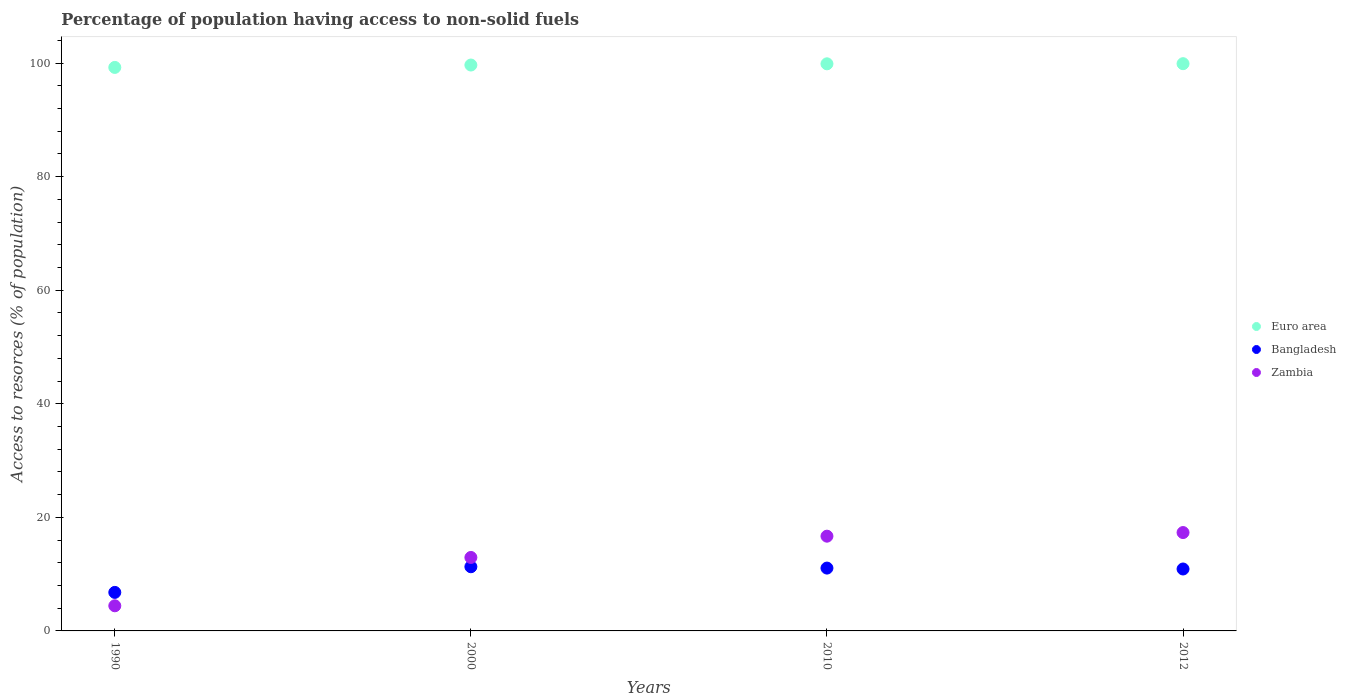What is the percentage of population having access to non-solid fuels in Euro area in 2010?
Offer a very short reply. 99.87. Across all years, what is the maximum percentage of population having access to non-solid fuels in Zambia?
Offer a terse response. 17.32. Across all years, what is the minimum percentage of population having access to non-solid fuels in Bangladesh?
Keep it short and to the point. 6.78. In which year was the percentage of population having access to non-solid fuels in Euro area minimum?
Your answer should be very brief. 1990. What is the total percentage of population having access to non-solid fuels in Euro area in the graph?
Ensure brevity in your answer.  398.65. What is the difference between the percentage of population having access to non-solid fuels in Euro area in 1990 and that in 2010?
Offer a very short reply. -0.64. What is the difference between the percentage of population having access to non-solid fuels in Zambia in 2000 and the percentage of population having access to non-solid fuels in Euro area in 2010?
Your answer should be compact. -86.93. What is the average percentage of population having access to non-solid fuels in Euro area per year?
Provide a succinct answer. 99.66. In the year 2012, what is the difference between the percentage of population having access to non-solid fuels in Bangladesh and percentage of population having access to non-solid fuels in Euro area?
Provide a short and direct response. -88.99. What is the ratio of the percentage of population having access to non-solid fuels in Bangladesh in 1990 to that in 2000?
Your response must be concise. 0.6. What is the difference between the highest and the second highest percentage of population having access to non-solid fuels in Euro area?
Make the answer very short. 0.02. What is the difference between the highest and the lowest percentage of population having access to non-solid fuels in Euro area?
Provide a succinct answer. 0.66. Is the sum of the percentage of population having access to non-solid fuels in Zambia in 1990 and 2000 greater than the maximum percentage of population having access to non-solid fuels in Euro area across all years?
Provide a short and direct response. No. Does the percentage of population having access to non-solid fuels in Zambia monotonically increase over the years?
Your answer should be very brief. Yes. Is the percentage of population having access to non-solid fuels in Bangladesh strictly greater than the percentage of population having access to non-solid fuels in Zambia over the years?
Give a very brief answer. No. How many years are there in the graph?
Offer a very short reply. 4. Does the graph contain grids?
Keep it short and to the point. No. Where does the legend appear in the graph?
Make the answer very short. Center right. How many legend labels are there?
Provide a short and direct response. 3. How are the legend labels stacked?
Provide a succinct answer. Vertical. What is the title of the graph?
Make the answer very short. Percentage of population having access to non-solid fuels. What is the label or title of the Y-axis?
Ensure brevity in your answer.  Access to resorces (% of population). What is the Access to resorces (% of population) in Euro area in 1990?
Your response must be concise. 99.23. What is the Access to resorces (% of population) in Bangladesh in 1990?
Ensure brevity in your answer.  6.78. What is the Access to resorces (% of population) in Zambia in 1990?
Offer a terse response. 4.42. What is the Access to resorces (% of population) of Euro area in 2000?
Your response must be concise. 99.66. What is the Access to resorces (% of population) in Bangladesh in 2000?
Offer a very short reply. 11.3. What is the Access to resorces (% of population) in Zambia in 2000?
Make the answer very short. 12.94. What is the Access to resorces (% of population) of Euro area in 2010?
Your response must be concise. 99.87. What is the Access to resorces (% of population) in Bangladesh in 2010?
Your response must be concise. 11.07. What is the Access to resorces (% of population) of Zambia in 2010?
Give a very brief answer. 16.69. What is the Access to resorces (% of population) of Euro area in 2012?
Your answer should be compact. 99.89. What is the Access to resorces (% of population) in Bangladesh in 2012?
Provide a succinct answer. 10.91. What is the Access to resorces (% of population) in Zambia in 2012?
Your answer should be very brief. 17.32. Across all years, what is the maximum Access to resorces (% of population) in Euro area?
Give a very brief answer. 99.89. Across all years, what is the maximum Access to resorces (% of population) of Bangladesh?
Give a very brief answer. 11.3. Across all years, what is the maximum Access to resorces (% of population) of Zambia?
Keep it short and to the point. 17.32. Across all years, what is the minimum Access to resorces (% of population) of Euro area?
Your answer should be compact. 99.23. Across all years, what is the minimum Access to resorces (% of population) in Bangladesh?
Give a very brief answer. 6.78. Across all years, what is the minimum Access to resorces (% of population) in Zambia?
Make the answer very short. 4.42. What is the total Access to resorces (% of population) of Euro area in the graph?
Make the answer very short. 398.65. What is the total Access to resorces (% of population) of Bangladesh in the graph?
Provide a succinct answer. 40.06. What is the total Access to resorces (% of population) of Zambia in the graph?
Give a very brief answer. 51.37. What is the difference between the Access to resorces (% of population) in Euro area in 1990 and that in 2000?
Make the answer very short. -0.42. What is the difference between the Access to resorces (% of population) in Bangladesh in 1990 and that in 2000?
Offer a very short reply. -4.52. What is the difference between the Access to resorces (% of population) of Zambia in 1990 and that in 2000?
Give a very brief answer. -8.51. What is the difference between the Access to resorces (% of population) in Euro area in 1990 and that in 2010?
Offer a very short reply. -0.64. What is the difference between the Access to resorces (% of population) in Bangladesh in 1990 and that in 2010?
Keep it short and to the point. -4.28. What is the difference between the Access to resorces (% of population) of Zambia in 1990 and that in 2010?
Provide a short and direct response. -12.26. What is the difference between the Access to resorces (% of population) of Euro area in 1990 and that in 2012?
Keep it short and to the point. -0.66. What is the difference between the Access to resorces (% of population) of Bangladesh in 1990 and that in 2012?
Your answer should be compact. -4.12. What is the difference between the Access to resorces (% of population) of Zambia in 1990 and that in 2012?
Your response must be concise. -12.9. What is the difference between the Access to resorces (% of population) of Euro area in 2000 and that in 2010?
Offer a terse response. -0.21. What is the difference between the Access to resorces (% of population) of Bangladesh in 2000 and that in 2010?
Offer a very short reply. 0.24. What is the difference between the Access to resorces (% of population) in Zambia in 2000 and that in 2010?
Provide a succinct answer. -3.75. What is the difference between the Access to resorces (% of population) in Euro area in 2000 and that in 2012?
Your answer should be very brief. -0.24. What is the difference between the Access to resorces (% of population) of Bangladesh in 2000 and that in 2012?
Make the answer very short. 0.4. What is the difference between the Access to resorces (% of population) in Zambia in 2000 and that in 2012?
Provide a succinct answer. -4.38. What is the difference between the Access to resorces (% of population) of Euro area in 2010 and that in 2012?
Your answer should be compact. -0.02. What is the difference between the Access to resorces (% of population) in Bangladesh in 2010 and that in 2012?
Your answer should be compact. 0.16. What is the difference between the Access to resorces (% of population) of Zambia in 2010 and that in 2012?
Offer a terse response. -0.64. What is the difference between the Access to resorces (% of population) of Euro area in 1990 and the Access to resorces (% of population) of Bangladesh in 2000?
Make the answer very short. 87.93. What is the difference between the Access to resorces (% of population) in Euro area in 1990 and the Access to resorces (% of population) in Zambia in 2000?
Your answer should be very brief. 86.3. What is the difference between the Access to resorces (% of population) in Bangladesh in 1990 and the Access to resorces (% of population) in Zambia in 2000?
Offer a very short reply. -6.15. What is the difference between the Access to resorces (% of population) of Euro area in 1990 and the Access to resorces (% of population) of Bangladesh in 2010?
Offer a very short reply. 88.17. What is the difference between the Access to resorces (% of population) of Euro area in 1990 and the Access to resorces (% of population) of Zambia in 2010?
Offer a terse response. 82.55. What is the difference between the Access to resorces (% of population) in Bangladesh in 1990 and the Access to resorces (% of population) in Zambia in 2010?
Give a very brief answer. -9.9. What is the difference between the Access to resorces (% of population) in Euro area in 1990 and the Access to resorces (% of population) in Bangladesh in 2012?
Your answer should be compact. 88.33. What is the difference between the Access to resorces (% of population) of Euro area in 1990 and the Access to resorces (% of population) of Zambia in 2012?
Provide a succinct answer. 81.91. What is the difference between the Access to resorces (% of population) of Bangladesh in 1990 and the Access to resorces (% of population) of Zambia in 2012?
Give a very brief answer. -10.54. What is the difference between the Access to resorces (% of population) of Euro area in 2000 and the Access to resorces (% of population) of Bangladesh in 2010?
Offer a very short reply. 88.59. What is the difference between the Access to resorces (% of population) of Euro area in 2000 and the Access to resorces (% of population) of Zambia in 2010?
Offer a terse response. 82.97. What is the difference between the Access to resorces (% of population) of Bangladesh in 2000 and the Access to resorces (% of population) of Zambia in 2010?
Keep it short and to the point. -5.38. What is the difference between the Access to resorces (% of population) of Euro area in 2000 and the Access to resorces (% of population) of Bangladesh in 2012?
Offer a terse response. 88.75. What is the difference between the Access to resorces (% of population) of Euro area in 2000 and the Access to resorces (% of population) of Zambia in 2012?
Offer a terse response. 82.33. What is the difference between the Access to resorces (% of population) in Bangladesh in 2000 and the Access to resorces (% of population) in Zambia in 2012?
Provide a short and direct response. -6.02. What is the difference between the Access to resorces (% of population) of Euro area in 2010 and the Access to resorces (% of population) of Bangladesh in 2012?
Your answer should be very brief. 88.96. What is the difference between the Access to resorces (% of population) in Euro area in 2010 and the Access to resorces (% of population) in Zambia in 2012?
Your response must be concise. 82.55. What is the difference between the Access to resorces (% of population) in Bangladesh in 2010 and the Access to resorces (% of population) in Zambia in 2012?
Keep it short and to the point. -6.26. What is the average Access to resorces (% of population) in Euro area per year?
Your response must be concise. 99.66. What is the average Access to resorces (% of population) in Bangladesh per year?
Make the answer very short. 10.01. What is the average Access to resorces (% of population) of Zambia per year?
Your response must be concise. 12.84. In the year 1990, what is the difference between the Access to resorces (% of population) of Euro area and Access to resorces (% of population) of Bangladesh?
Give a very brief answer. 92.45. In the year 1990, what is the difference between the Access to resorces (% of population) in Euro area and Access to resorces (% of population) in Zambia?
Make the answer very short. 94.81. In the year 1990, what is the difference between the Access to resorces (% of population) in Bangladesh and Access to resorces (% of population) in Zambia?
Make the answer very short. 2.36. In the year 2000, what is the difference between the Access to resorces (% of population) in Euro area and Access to resorces (% of population) in Bangladesh?
Your answer should be very brief. 88.35. In the year 2000, what is the difference between the Access to resorces (% of population) in Euro area and Access to resorces (% of population) in Zambia?
Ensure brevity in your answer.  86.72. In the year 2000, what is the difference between the Access to resorces (% of population) of Bangladesh and Access to resorces (% of population) of Zambia?
Ensure brevity in your answer.  -1.64. In the year 2010, what is the difference between the Access to resorces (% of population) of Euro area and Access to resorces (% of population) of Bangladesh?
Ensure brevity in your answer.  88.8. In the year 2010, what is the difference between the Access to resorces (% of population) in Euro area and Access to resorces (% of population) in Zambia?
Make the answer very short. 83.18. In the year 2010, what is the difference between the Access to resorces (% of population) in Bangladesh and Access to resorces (% of population) in Zambia?
Make the answer very short. -5.62. In the year 2012, what is the difference between the Access to resorces (% of population) in Euro area and Access to resorces (% of population) in Bangladesh?
Your answer should be very brief. 88.99. In the year 2012, what is the difference between the Access to resorces (% of population) in Euro area and Access to resorces (% of population) in Zambia?
Make the answer very short. 82.57. In the year 2012, what is the difference between the Access to resorces (% of population) of Bangladesh and Access to resorces (% of population) of Zambia?
Give a very brief answer. -6.42. What is the ratio of the Access to resorces (% of population) of Bangladesh in 1990 to that in 2000?
Offer a terse response. 0.6. What is the ratio of the Access to resorces (% of population) in Zambia in 1990 to that in 2000?
Provide a succinct answer. 0.34. What is the ratio of the Access to resorces (% of population) of Euro area in 1990 to that in 2010?
Your answer should be very brief. 0.99. What is the ratio of the Access to resorces (% of population) of Bangladesh in 1990 to that in 2010?
Your answer should be very brief. 0.61. What is the ratio of the Access to resorces (% of population) of Zambia in 1990 to that in 2010?
Provide a succinct answer. 0.27. What is the ratio of the Access to resorces (% of population) of Euro area in 1990 to that in 2012?
Your answer should be compact. 0.99. What is the ratio of the Access to resorces (% of population) of Bangladesh in 1990 to that in 2012?
Give a very brief answer. 0.62. What is the ratio of the Access to resorces (% of population) of Zambia in 1990 to that in 2012?
Offer a very short reply. 0.26. What is the ratio of the Access to resorces (% of population) of Bangladesh in 2000 to that in 2010?
Ensure brevity in your answer.  1.02. What is the ratio of the Access to resorces (% of population) of Zambia in 2000 to that in 2010?
Offer a terse response. 0.78. What is the ratio of the Access to resorces (% of population) in Bangladesh in 2000 to that in 2012?
Your answer should be very brief. 1.04. What is the ratio of the Access to resorces (% of population) in Zambia in 2000 to that in 2012?
Provide a succinct answer. 0.75. What is the ratio of the Access to resorces (% of population) of Euro area in 2010 to that in 2012?
Give a very brief answer. 1. What is the ratio of the Access to resorces (% of population) of Bangladesh in 2010 to that in 2012?
Ensure brevity in your answer.  1.01. What is the ratio of the Access to resorces (% of population) in Zambia in 2010 to that in 2012?
Provide a short and direct response. 0.96. What is the difference between the highest and the second highest Access to resorces (% of population) of Euro area?
Provide a short and direct response. 0.02. What is the difference between the highest and the second highest Access to resorces (% of population) of Bangladesh?
Provide a succinct answer. 0.24. What is the difference between the highest and the second highest Access to resorces (% of population) of Zambia?
Give a very brief answer. 0.64. What is the difference between the highest and the lowest Access to resorces (% of population) of Euro area?
Keep it short and to the point. 0.66. What is the difference between the highest and the lowest Access to resorces (% of population) in Bangladesh?
Provide a short and direct response. 4.52. What is the difference between the highest and the lowest Access to resorces (% of population) of Zambia?
Ensure brevity in your answer.  12.9. 